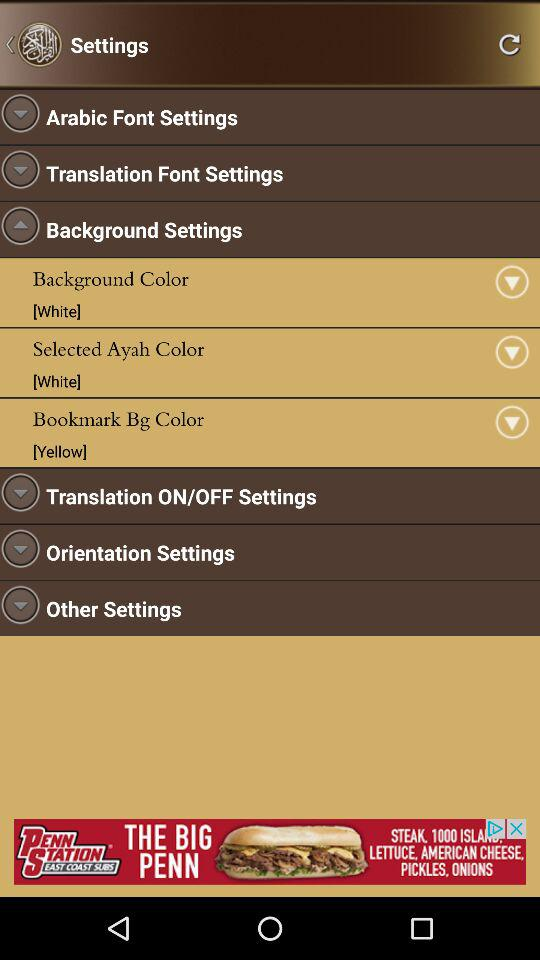What is the selected Bg color? The selected Bg color is yellow. 